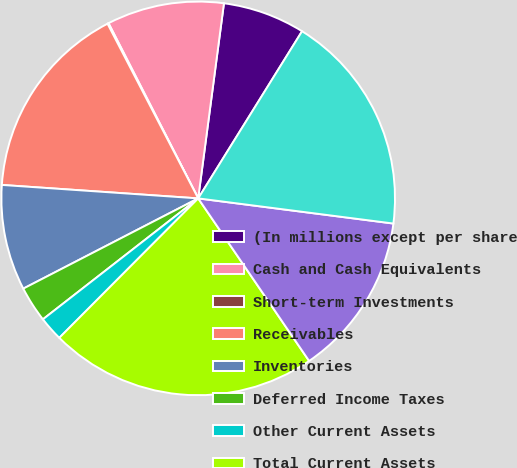Convert chart. <chart><loc_0><loc_0><loc_500><loc_500><pie_chart><fcel>(In millions except per share<fcel>Cash and Cash Equivalents<fcel>Short-term Investments<fcel>Receivables<fcel>Inventories<fcel>Deferred Income Taxes<fcel>Other Current Assets<fcel>Total Current Assets<fcel>Property Plant and Equipment<fcel>Goodwill<nl><fcel>6.76%<fcel>9.62%<fcel>0.09%<fcel>16.29%<fcel>8.67%<fcel>2.95%<fcel>2.0%<fcel>22.0%<fcel>13.43%<fcel>18.19%<nl></chart> 